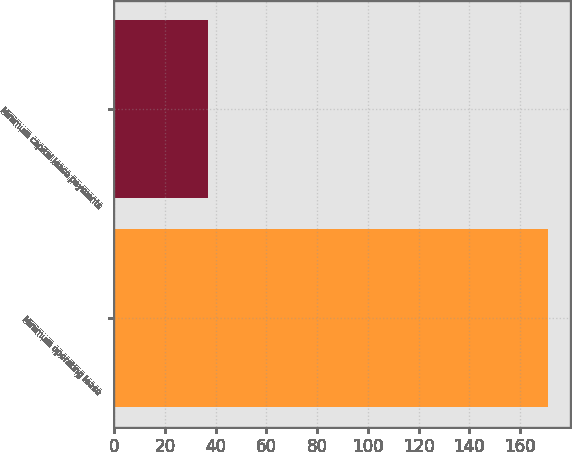Convert chart. <chart><loc_0><loc_0><loc_500><loc_500><bar_chart><fcel>Minimum operating lease<fcel>Minimum capital lease payments<nl><fcel>171<fcel>37<nl></chart> 